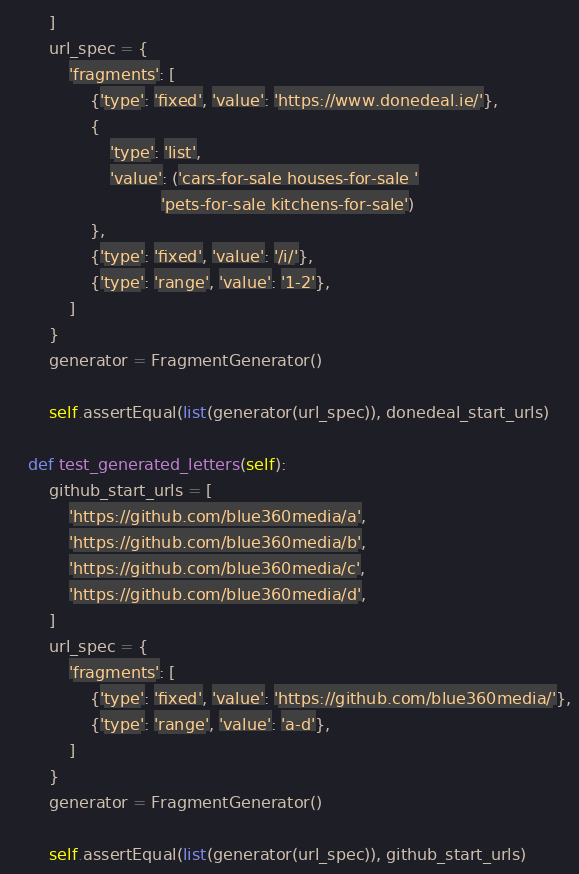Convert code to text. <code><loc_0><loc_0><loc_500><loc_500><_Python_>        ]
        url_spec = {
            'fragments': [
                {'type': 'fixed', 'value': 'https://www.donedeal.ie/'},
                {
                    'type': 'list',
                    'value': ('cars-for-sale houses-for-sale '
                              'pets-for-sale kitchens-for-sale')
                },
                {'type': 'fixed', 'value': '/i/'},
                {'type': 'range', 'value': '1-2'},
            ]
        }
        generator = FragmentGenerator()

        self.assertEqual(list(generator(url_spec)), donedeal_start_urls)

    def test_generated_letters(self):
        github_start_urls = [
            'https://github.com/blue360media/a',
            'https://github.com/blue360media/b',
            'https://github.com/blue360media/c',
            'https://github.com/blue360media/d',
        ]
        url_spec = {
            'fragments': [
                {'type': 'fixed', 'value': 'https://github.com/blue360media/'},
                {'type': 'range', 'value': 'a-d'},
            ]
        }
        generator = FragmentGenerator()

        self.assertEqual(list(generator(url_spec)), github_start_urls)
</code> 